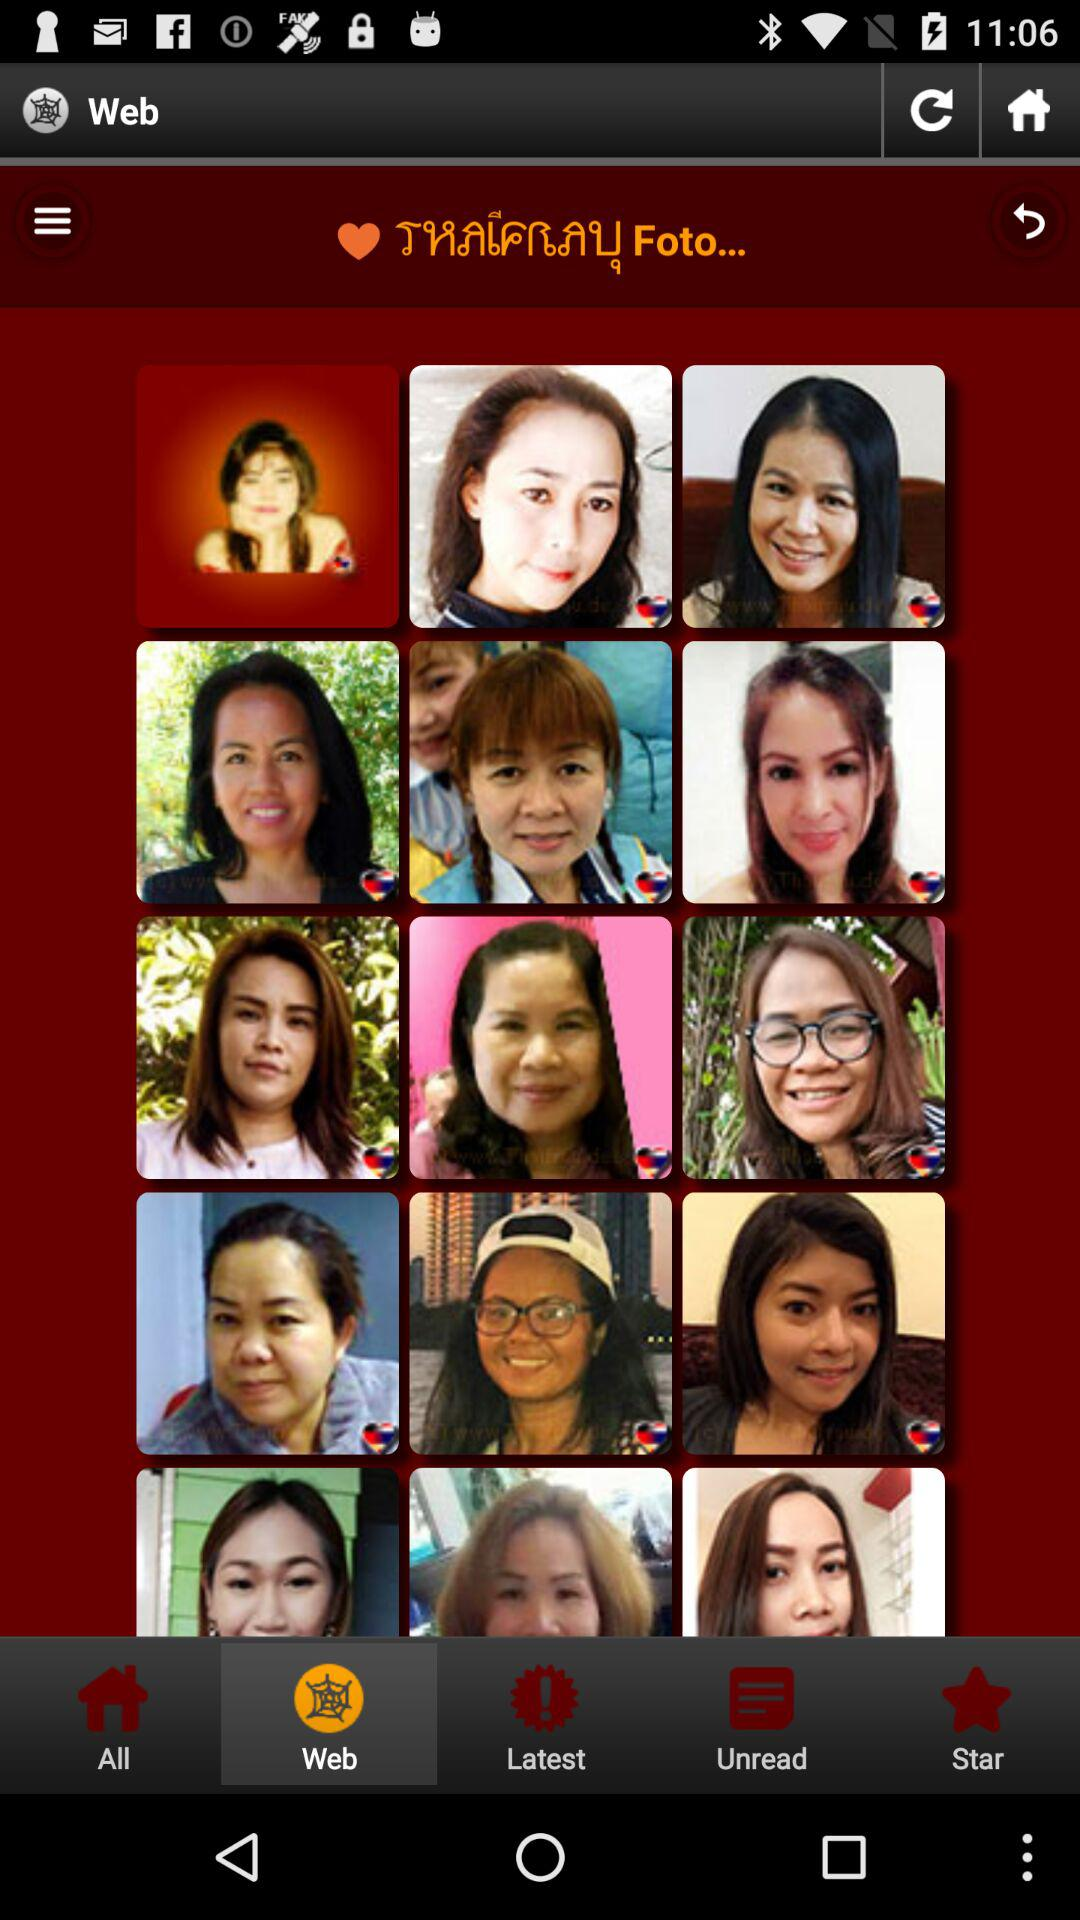Which tab is selected? The selected tab is "Web". 